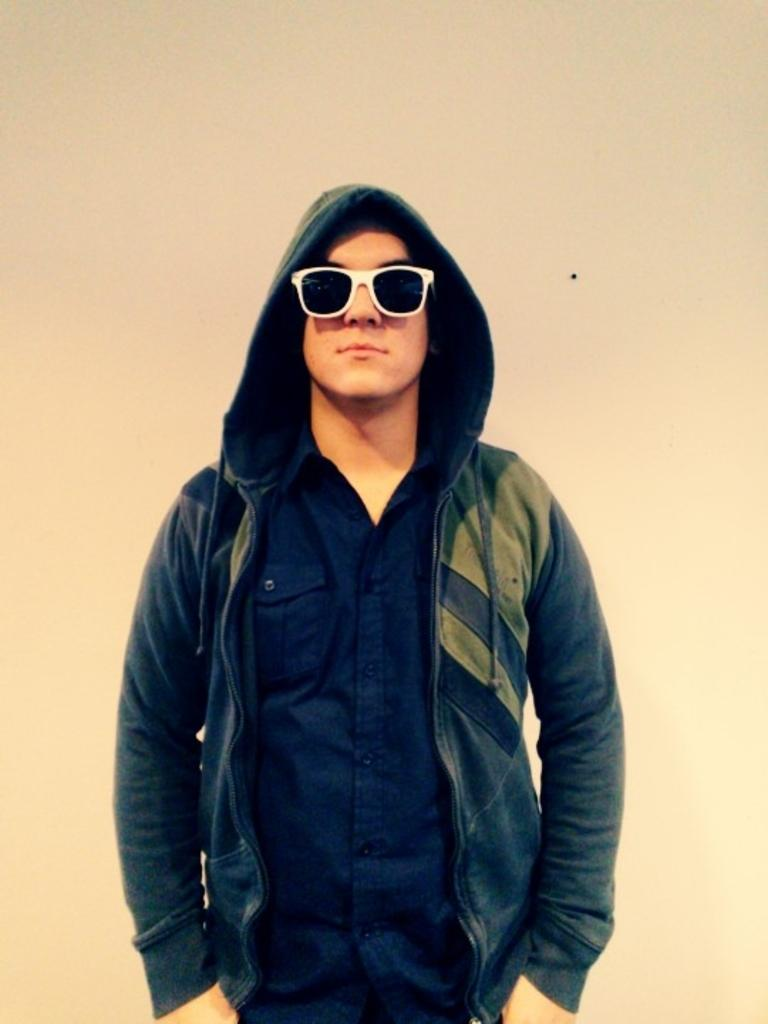Who is present in the image? There is a man in the picture. What is the man wearing on his face? The man is wearing goggles. What type of clothing is the man wearing on his upper body? The man is wearing a hoodie. What is the man's posture in the image? The man is standing. What type of doctor is present in the image? There is no doctor present in the image; it features a man wearing goggles and a hoodie. What type of wood can be seen in the image? There is no wood present in the image. 